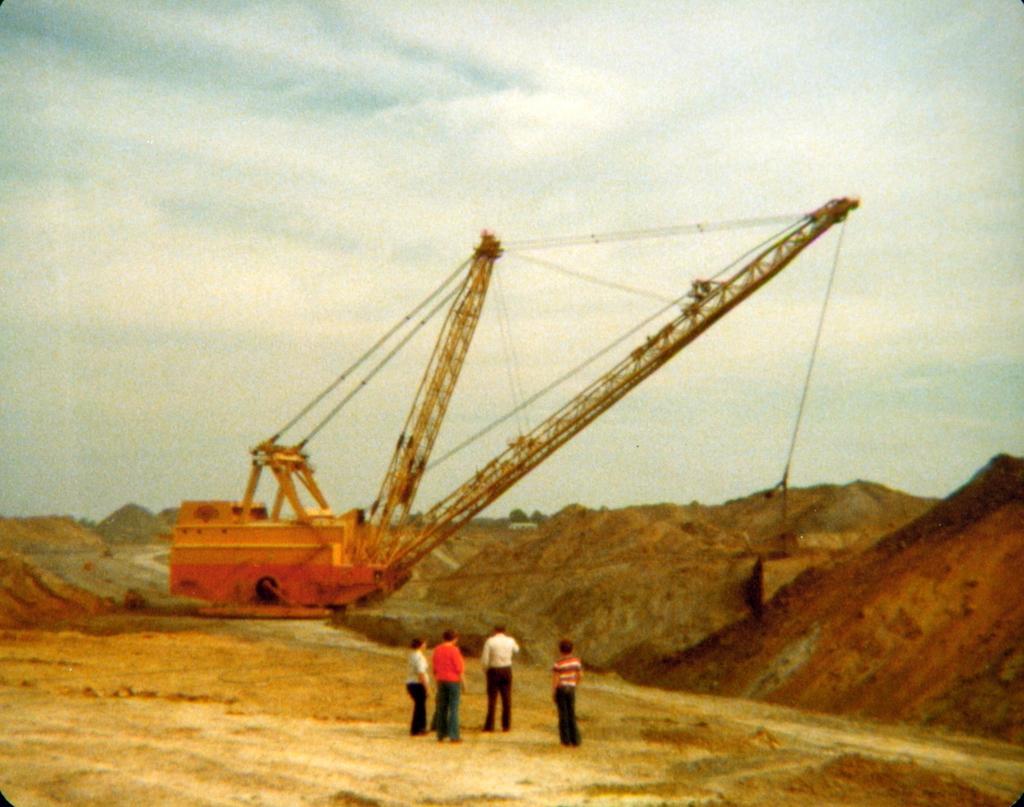Could you give a brief overview of what you see in this image? In this picture we can see group of people, they are standing in front of the crane. 